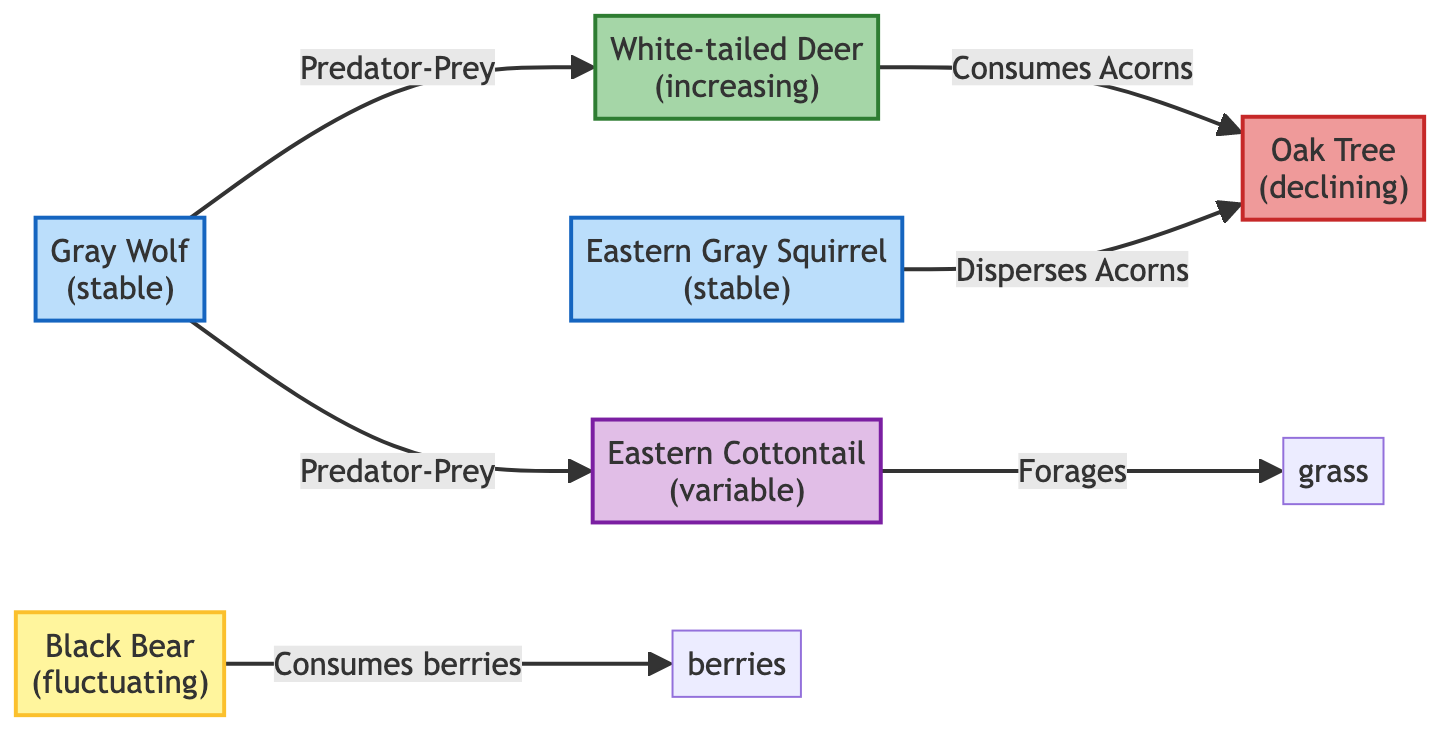What is the population trend of the Eastern Gray Squirrel? The diagram indicates that the Eastern Gray Squirrel has a stable population trend, which is labeled next to the species in the diagram.
Answer: stable How many species are depicted in the diagram? The diagram shows a total of six species: White-tailed Deer, Gray Wolf, Black Bear, Oak Tree, Eastern Cottontail, and Eastern Gray Squirrel. By counting each species listed, we confirm the total.
Answer: 6 What type of relationship exists between the Gray Wolf and White-tailed Deer? The diagram identifies a predator-prey relationship between the Gray Wolf and the White-tailed Deer, indicated by the label connecting them.
Answer: Predator-Prey Which species is consuming acorns? The White-tailed Deer and the Eastern Gray Squirrel are both indicated as consuming or interacting with acorns in the diagram.
Answer: White-tailed Deer and Eastern Gray Squirrel What is the population trend of the Oak Tree? The Oak Tree is indicated to be in a declining population trend as labeled in the diagram.
Answer: declining Which species is indicated as having a fluctuating population? The diagram labels the Black Bear as having a fluctuating population trend. This is shown directly in the diagram.
Answer: fluctuating What kind of interaction does the Black Bear have with berries? The Black Bear is shown as consuming berries in the diagram, which indicates a foraging relationship.
Answer: Consumes berries How many stable population species are represented in the diagram? The diagram presents two species with stable populations: the Gray Wolf and the Eastern Gray Squirrel. Counting these gives the answer.
Answer: 2 What type of population trend does the Eastern Cottontail exhibit? According to the diagram, the Eastern Cottontail has a variable population trend, which is specified in the diagram.
Answer: variable 